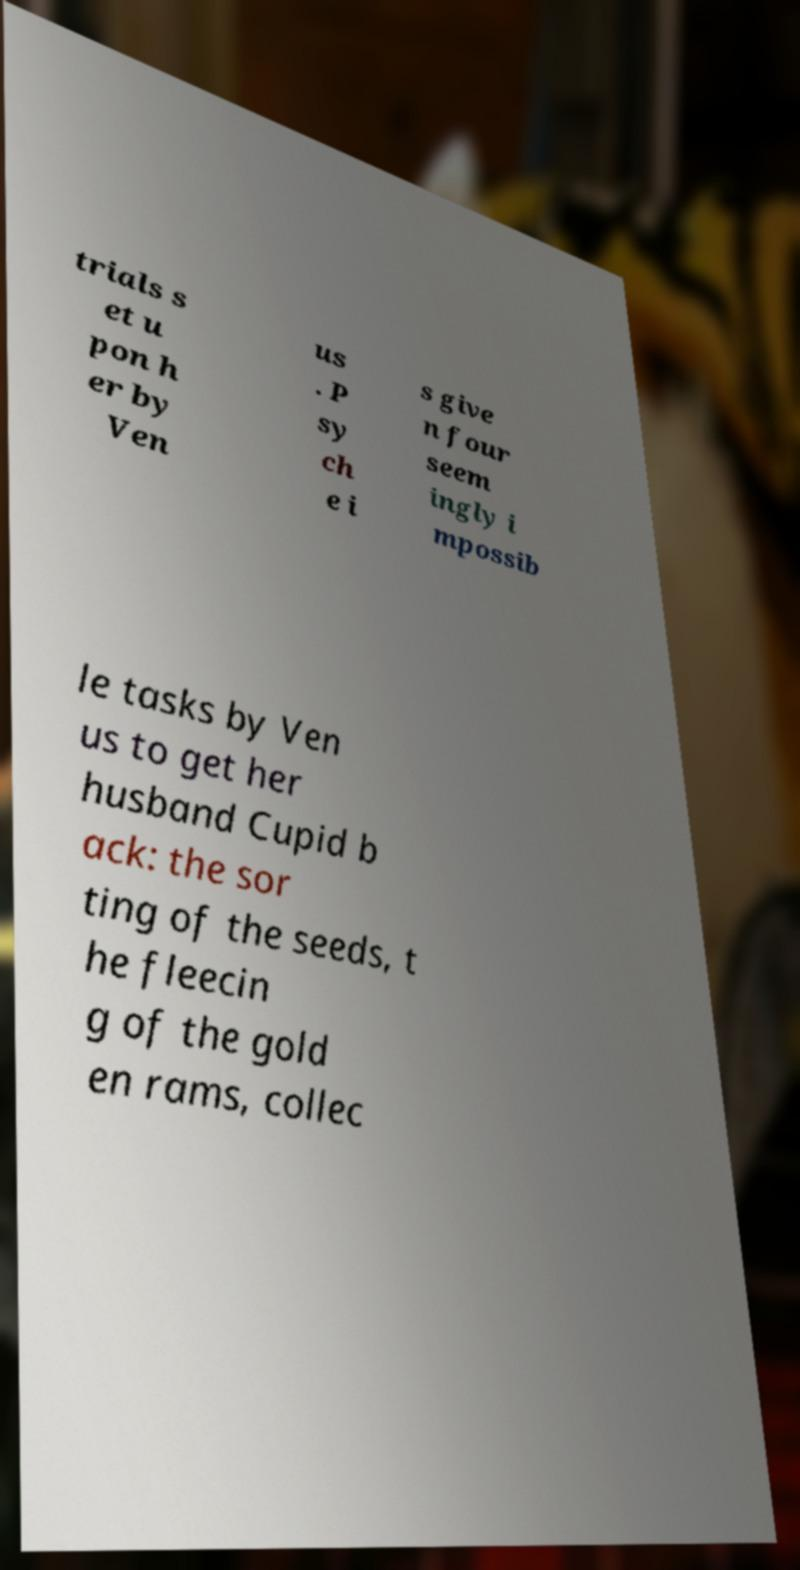Can you accurately transcribe the text from the provided image for me? trials s et u pon h er by Ven us . P sy ch e i s give n four seem ingly i mpossib le tasks by Ven us to get her husband Cupid b ack: the sor ting of the seeds, t he fleecin g of the gold en rams, collec 